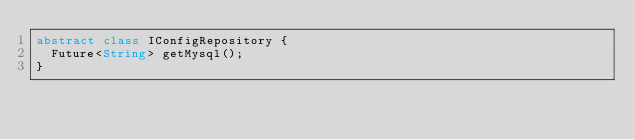Convert code to text. <code><loc_0><loc_0><loc_500><loc_500><_Dart_>abstract class IConfigRepository {
  Future<String> getMysql();
}
</code> 